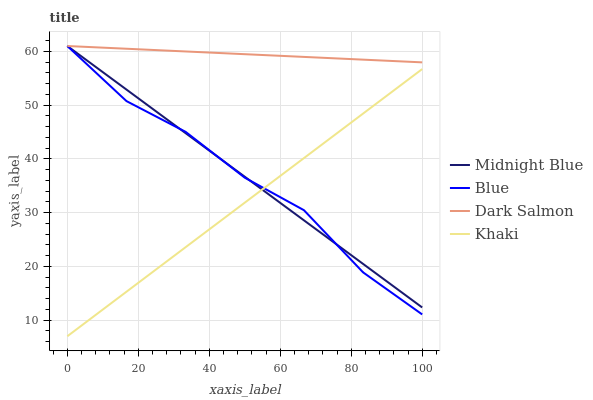Does Khaki have the minimum area under the curve?
Answer yes or no. Yes. Does Dark Salmon have the maximum area under the curve?
Answer yes or no. Yes. Does Midnight Blue have the minimum area under the curve?
Answer yes or no. No. Does Midnight Blue have the maximum area under the curve?
Answer yes or no. No. Is Khaki the smoothest?
Answer yes or no. Yes. Is Blue the roughest?
Answer yes or no. Yes. Is Dark Salmon the smoothest?
Answer yes or no. No. Is Dark Salmon the roughest?
Answer yes or no. No. Does Midnight Blue have the lowest value?
Answer yes or no. No. Does Khaki have the highest value?
Answer yes or no. No. Is Khaki less than Dark Salmon?
Answer yes or no. Yes. Is Dark Salmon greater than Khaki?
Answer yes or no. Yes. Does Khaki intersect Dark Salmon?
Answer yes or no. No. 